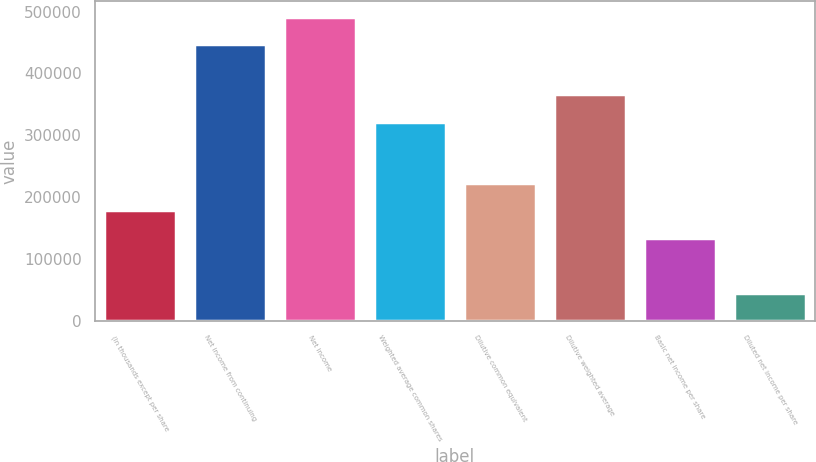Convert chart to OTSL. <chart><loc_0><loc_0><loc_500><loc_500><bar_chart><fcel>(In thousands except per share<fcel>Net income from continuing<fcel>Net income<fcel>Weighted average common shares<fcel>Dilutive common equivalent<fcel>Dilutive weighted average<fcel>Basic net income per share<fcel>Diluted net income per share<nl><fcel>178817<fcel>447041<fcel>491745<fcel>322280<fcel>223521<fcel>366984<fcel>134113<fcel>44705.3<nl></chart> 